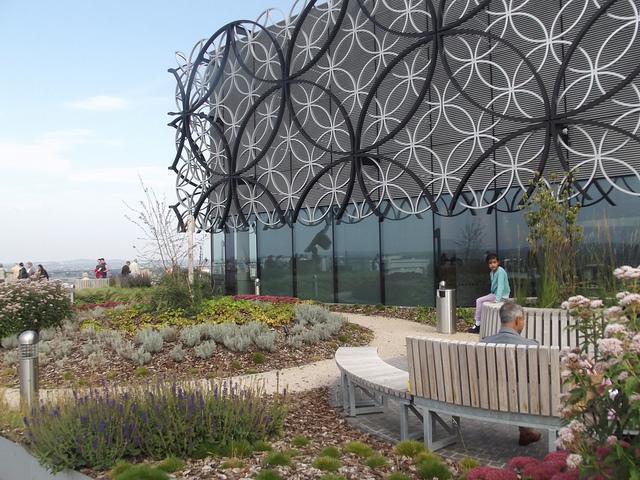What should be put in the hole near the nearby child?
Pick the correct solution from the four options below to address the question.
Options: Lightbulb, key, hand, trash. Trash. 